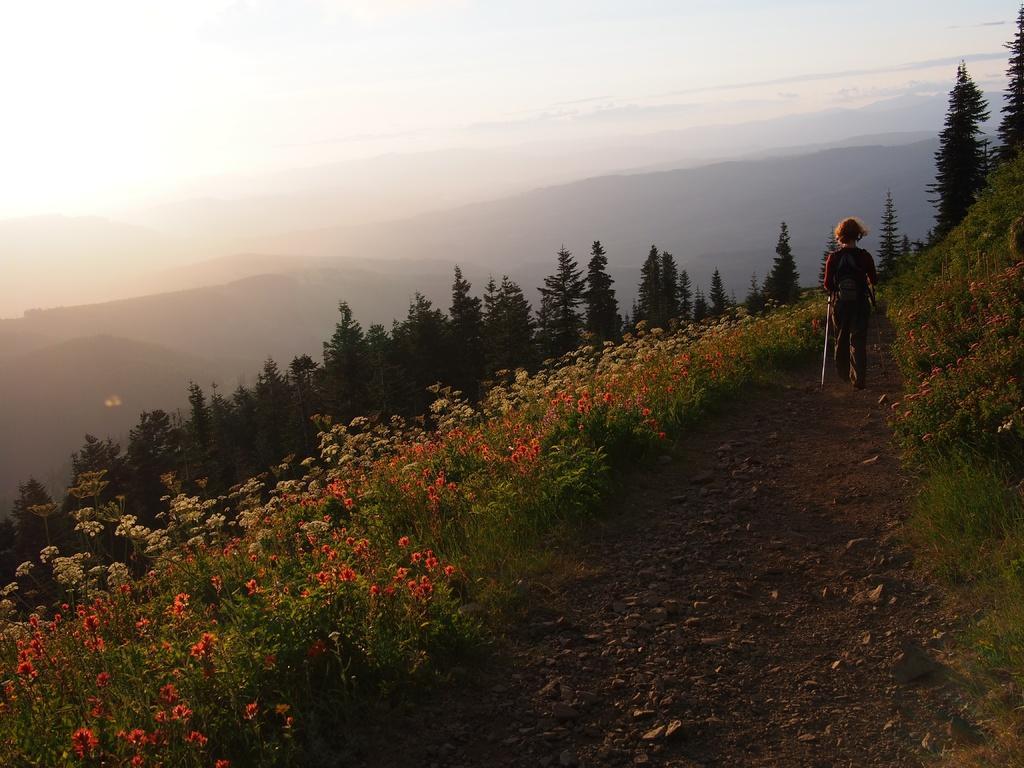In one or two sentences, can you explain what this image depicts? In the image I can see flower plants, trees and a person is walking on the ground. In the background I can see mountains and the sky. 